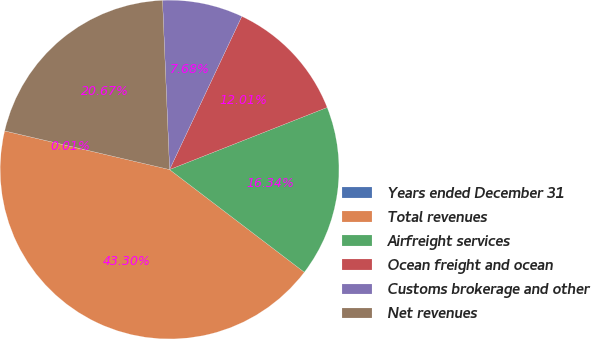Convert chart. <chart><loc_0><loc_0><loc_500><loc_500><pie_chart><fcel>Years ended December 31<fcel>Total revenues<fcel>Airfreight services<fcel>Ocean freight and ocean<fcel>Customs brokerage and other<fcel>Net revenues<nl><fcel>0.01%<fcel>43.3%<fcel>16.34%<fcel>12.01%<fcel>7.68%<fcel>20.67%<nl></chart> 